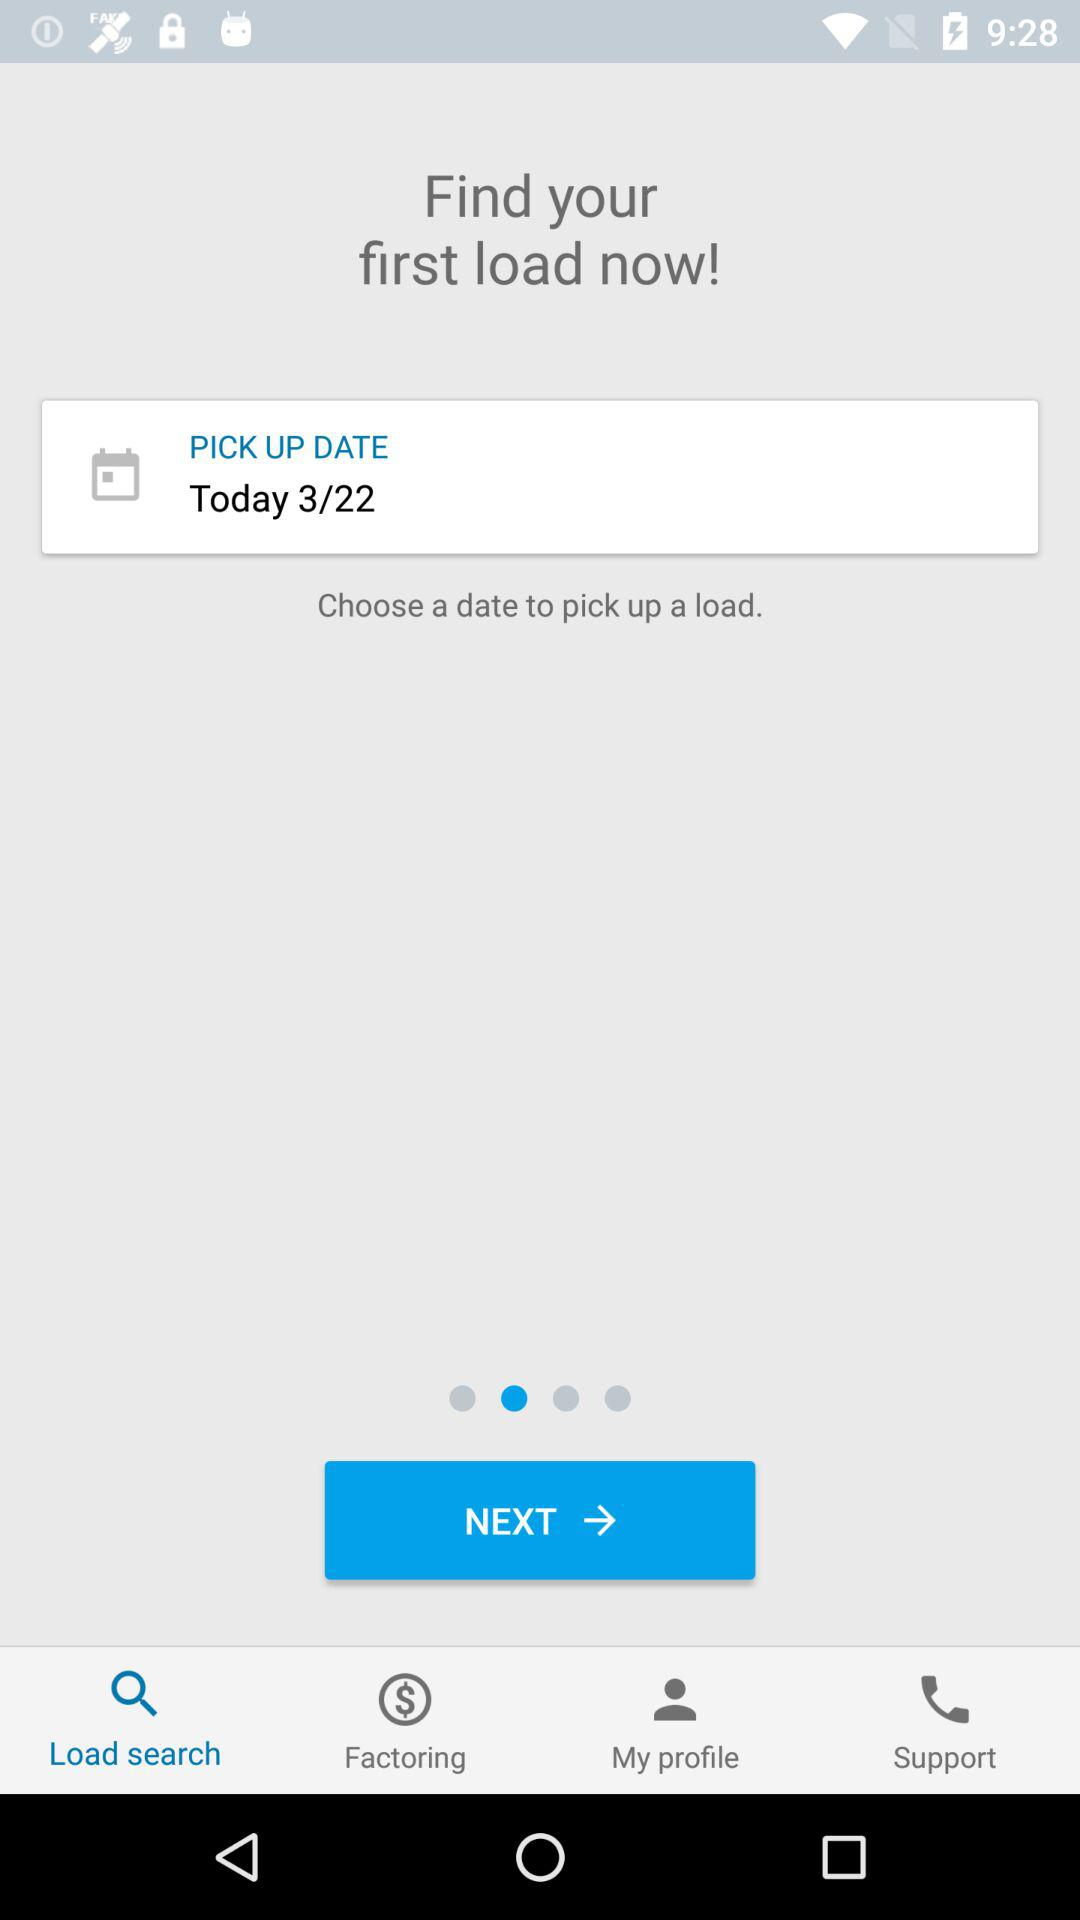What pickup date has been chosen? The chosen pickup date is March 22. 